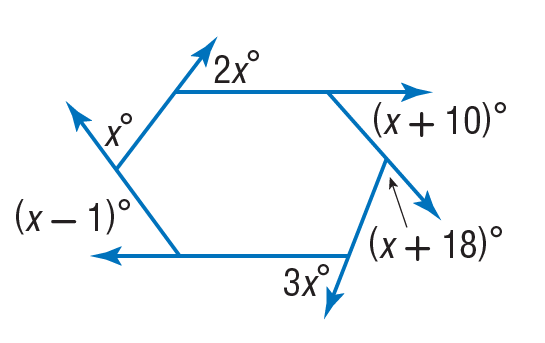Answer the mathemtical geometry problem and directly provide the correct option letter.
Question: Find the value of x in the diagram.
Choices: A: 36 B: 37 C: 38 D: 74 B 